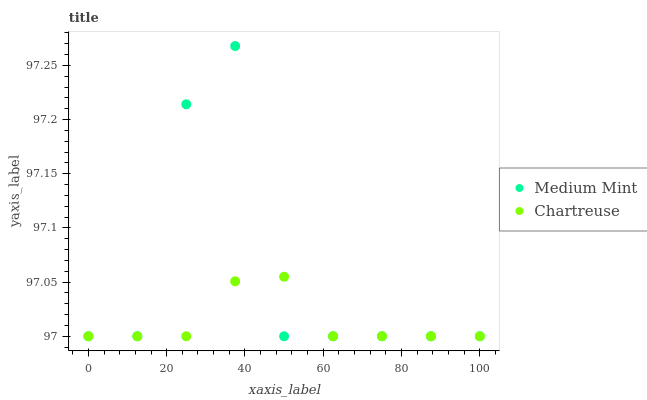Does Chartreuse have the minimum area under the curve?
Answer yes or no. Yes. Does Medium Mint have the maximum area under the curve?
Answer yes or no. Yes. Does Chartreuse have the maximum area under the curve?
Answer yes or no. No. Is Chartreuse the smoothest?
Answer yes or no. Yes. Is Medium Mint the roughest?
Answer yes or no. Yes. Is Chartreuse the roughest?
Answer yes or no. No. Does Medium Mint have the lowest value?
Answer yes or no. Yes. Does Medium Mint have the highest value?
Answer yes or no. Yes. Does Chartreuse have the highest value?
Answer yes or no. No. Does Medium Mint intersect Chartreuse?
Answer yes or no. Yes. Is Medium Mint less than Chartreuse?
Answer yes or no. No. Is Medium Mint greater than Chartreuse?
Answer yes or no. No. 